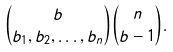Convert formula to latex. <formula><loc_0><loc_0><loc_500><loc_500>\binom { b } { b _ { 1 } , b _ { 2 } , \dots , b _ { n } } \binom { n } { b - 1 } .</formula> 